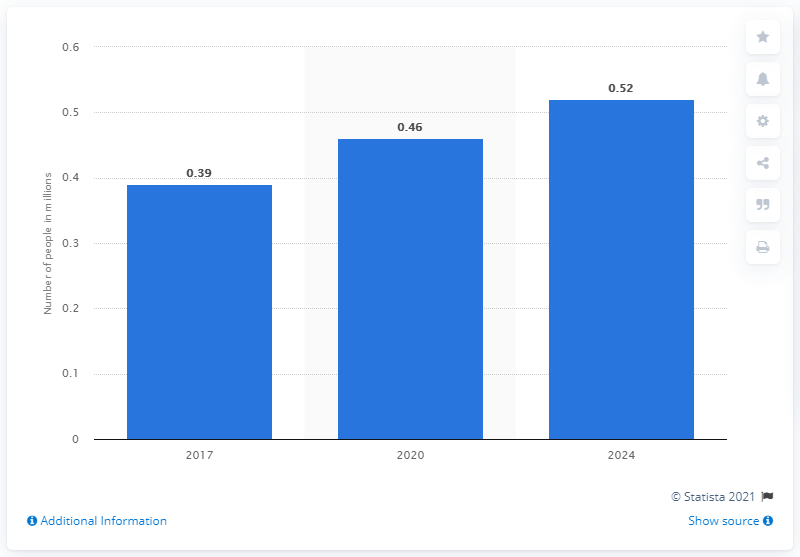List a handful of essential elements in this visual. The estimated number of patients suffering from Alzheimer's disease by 2024 is projected to be 0.52 million. By the year 2024, it is projected that the number of patients suffering from Alzheimer's disease will reach 518 thousand. 